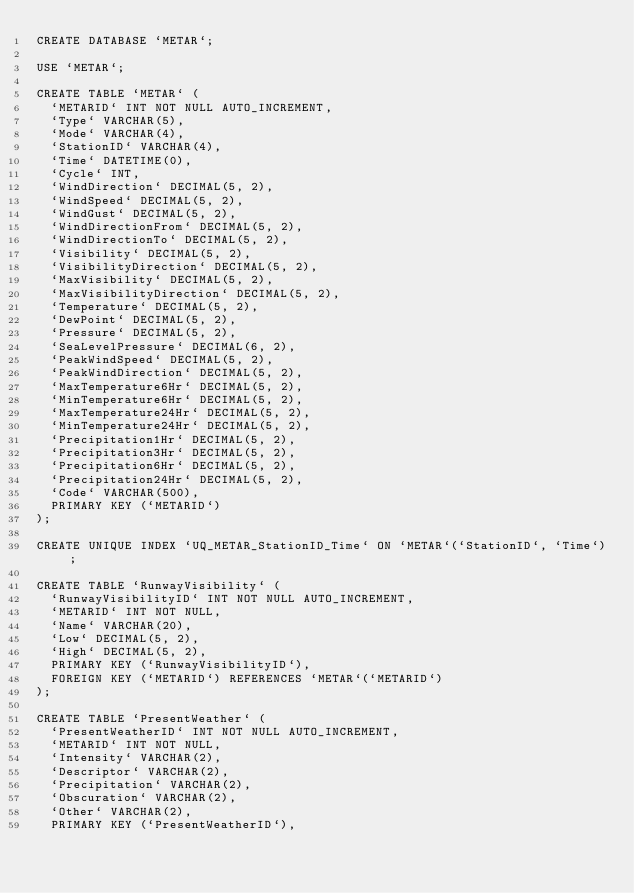Convert code to text. <code><loc_0><loc_0><loc_500><loc_500><_SQL_>CREATE DATABASE `METAR`;

USE `METAR`;

CREATE TABLE `METAR` (
  `METARID` INT NOT NULL AUTO_INCREMENT,
  `Type` VARCHAR(5),
  `Mode` VARCHAR(4),
  `StationID` VARCHAR(4),
  `Time` DATETIME(0),
  `Cycle` INT,
  `WindDirection` DECIMAL(5, 2),
  `WindSpeed` DECIMAL(5, 2),
  `WindGust` DECIMAL(5, 2),
  `WindDirectionFrom` DECIMAL(5, 2),
  `WindDirectionTo` DECIMAL(5, 2),
  `Visibility` DECIMAL(5, 2),
  `VisibilityDirection` DECIMAL(5, 2),
  `MaxVisibility` DECIMAL(5, 2),
  `MaxVisibilityDirection` DECIMAL(5, 2),
  `Temperature` DECIMAL(5, 2),
  `DewPoint` DECIMAL(5, 2),
  `Pressure` DECIMAL(5, 2),
  `SeaLevelPressure` DECIMAL(6, 2),
  `PeakWindSpeed` DECIMAL(5, 2),
  `PeakWindDirection` DECIMAL(5, 2),
  `MaxTemperature6Hr` DECIMAL(5, 2),
  `MinTemperature6Hr` DECIMAL(5, 2),
  `MaxTemperature24Hr` DECIMAL(5, 2),
  `MinTemperature24Hr` DECIMAL(5, 2),
  `Precipitation1Hr` DECIMAL(5, 2),
  `Precipitation3Hr` DECIMAL(5, 2),
  `Precipitation6Hr` DECIMAL(5, 2),
  `Precipitation24Hr` DECIMAL(5, 2),
  `Code` VARCHAR(500),
  PRIMARY KEY (`METARID`)
);

CREATE UNIQUE INDEX `UQ_METAR_StationID_Time` ON `METAR`(`StationID`, `Time`);

CREATE TABLE `RunwayVisibility` (
  `RunwayVisibilityID` INT NOT NULL AUTO_INCREMENT,
  `METARID` INT NOT NULL,
  `Name` VARCHAR(20),
  `Low` DECIMAL(5, 2),
  `High` DECIMAL(5, 2),
  PRIMARY KEY (`RunwayVisibilityID`),
  FOREIGN KEY (`METARID`) REFERENCES `METAR`(`METARID`)
);

CREATE TABLE `PresentWeather` (
  `PresentWeatherID` INT NOT NULL AUTO_INCREMENT,
  `METARID` INT NOT NULL,
  `Intensity` VARCHAR(2),
  `Descriptor` VARCHAR(2),
  `Precipitation` VARCHAR(2),
  `Obscuration` VARCHAR(2),
  `Other` VARCHAR(2),
  PRIMARY KEY (`PresentWeatherID`),</code> 